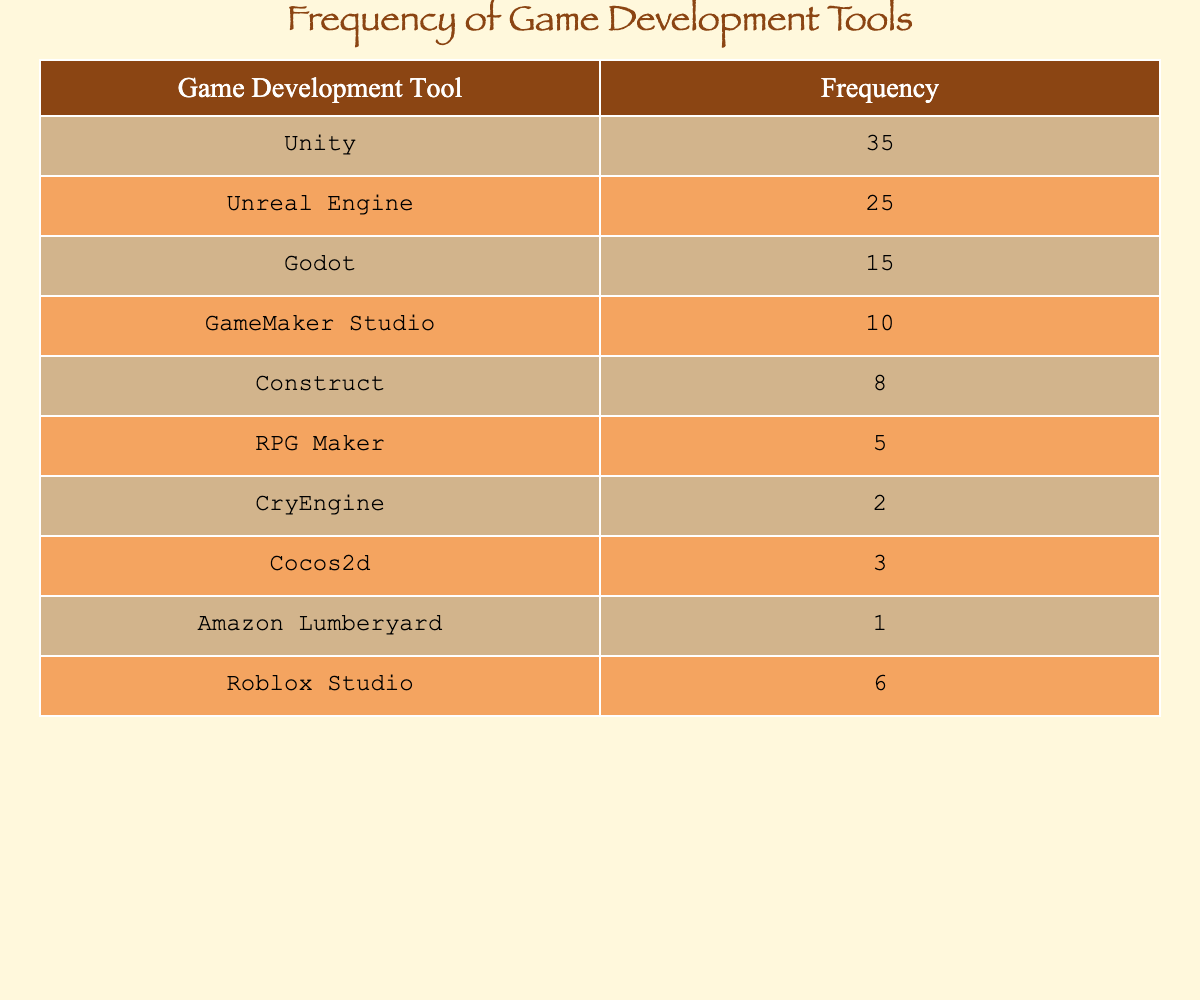What is the frequency of Unity as a game development tool? The table shows that the frequency of Unity is stated explicitly in one of the rows. It indicates that 35 developers use Unity as their game development tool.
Answer: 35 What is the total frequency of all the game development tools listed? To find the total frequency, we need to sum all the frequencies: 35 (Unity) + 25 (Unreal Engine) + 15 (Godot) + 10 (GameMaker Studio) + 8 (Construct) + 5 (RPG Maker) + 2 (CryEngine) + 3 (Cocos2d) + 1 (Amazon Lumberyard) + 6 (Roblox Studio) = 110.
Answer: 110 Is the frequency of RPG Maker greater than that of Construct? The frequency of RPG Maker is 5, and the frequency of Construct is 8. Since 5 is not greater than 8, the statement is false.
Answer: No Which game development tool is used the least by new developers? Looking at the frequencies listed, Amazon Lumberyard has the lowest frequency with only 1 developer using it.
Answer: Amazon Lumberyard What is the combined frequency of Godot, GameMaker Studio, and RPG Maker? To find the combined frequency of these three tools, we sum their individual frequencies: 15 (Godot) + 10 (GameMaker Studio) + 5 (RPG Maker) = 30.
Answer: 30 How many more developers use Unity than CryEngine? Unity has a frequency of 35, and CryEngine has a frequency of 2. The difference is calculated as 35 - 2 = 33.
Answer: 33 Which two game development tools combined have a frequency of 30? To find the combination of tools that equals 30, we check the frequencies of each tool. For example, Unreal Engine (25) and Construct (8) together do not equal 30. However, no combinations of two tools based on the provided data sum exactly to 30. Thus, there are no two tools that satisfy this condition.
Answer: None What percentage of developers use GameMaker Studio compared to the total? The total frequency is 110. The frequency of GameMaker Studio is 10. To find the percentage, we calculate (10 / 110) * 100 = 9.09%.
Answer: 9.09% Is Godot used more frequently than both CryEngine and Cocos2d combined? Godot has a frequency of 15, while CryEngine has a frequency of 2 and Cocos2d has a frequency of 3. Combining CryEngine and Cocos2d gives us 2 + 3 = 5. Since 15 is greater than 5, the statement is true.
Answer: Yes 